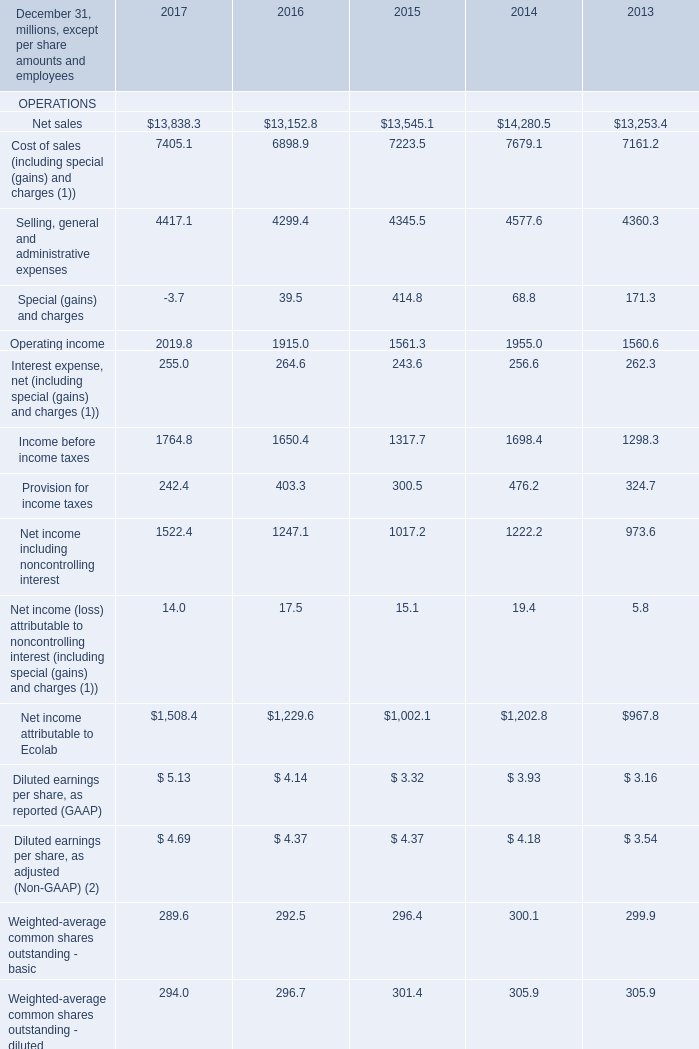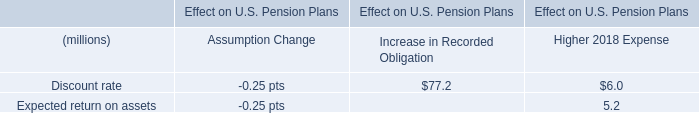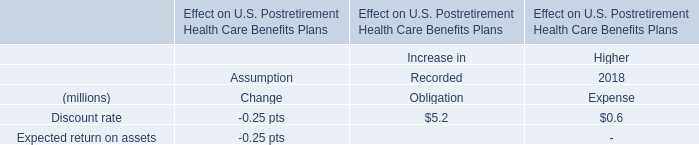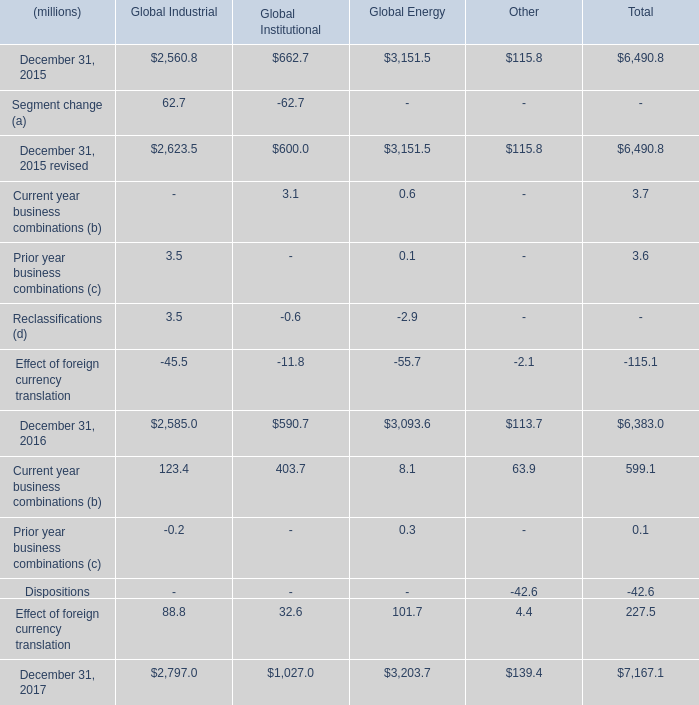What is the total amount of December 31, 2015 revised of Global Energy, and Ecolab shareholders’ equity FINANCIAL POSITION of 2014 ? 
Computations: (3151.5 + 7315.9)
Answer: 10467.4. 